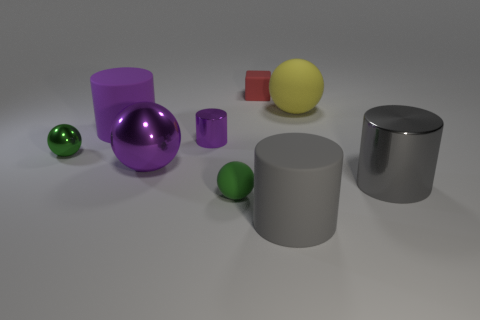Are there the same number of green metallic balls that are on the left side of the purple matte thing and small rubber objects behind the large yellow matte ball?
Make the answer very short. Yes. What number of objects are red rubber things or purple shiny balls?
Your answer should be compact. 2. What is the color of the metal cylinder that is the same size as the yellow matte object?
Keep it short and to the point. Gray. How many things are either large purple cylinders behind the gray matte thing or objects on the right side of the big purple shiny thing?
Provide a short and direct response. 7. Is the number of large purple cylinders that are in front of the large purple cylinder the same as the number of purple metal balls?
Your response must be concise. No. Is the size of the ball that is to the left of the purple rubber thing the same as the matte object to the left of the big purple ball?
Keep it short and to the point. No. What number of other things are the same size as the green rubber sphere?
Provide a succinct answer. 3. Is there a big gray shiny thing that is in front of the big gray object to the left of the ball behind the purple matte object?
Your answer should be very brief. No. Are there any other things of the same color as the small rubber sphere?
Provide a succinct answer. Yes. There is a gray cylinder in front of the large metal cylinder; how big is it?
Your response must be concise. Large. 